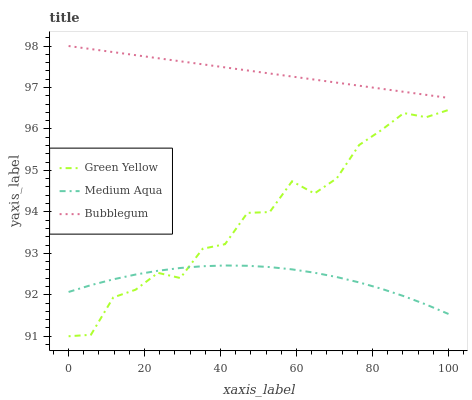Does Bubblegum have the minimum area under the curve?
Answer yes or no. No. Does Medium Aqua have the maximum area under the curve?
Answer yes or no. No. Is Medium Aqua the smoothest?
Answer yes or no. No. Is Medium Aqua the roughest?
Answer yes or no. No. Does Medium Aqua have the lowest value?
Answer yes or no. No. Does Medium Aqua have the highest value?
Answer yes or no. No. Is Medium Aqua less than Bubblegum?
Answer yes or no. Yes. Is Bubblegum greater than Medium Aqua?
Answer yes or no. Yes. Does Medium Aqua intersect Bubblegum?
Answer yes or no. No. 